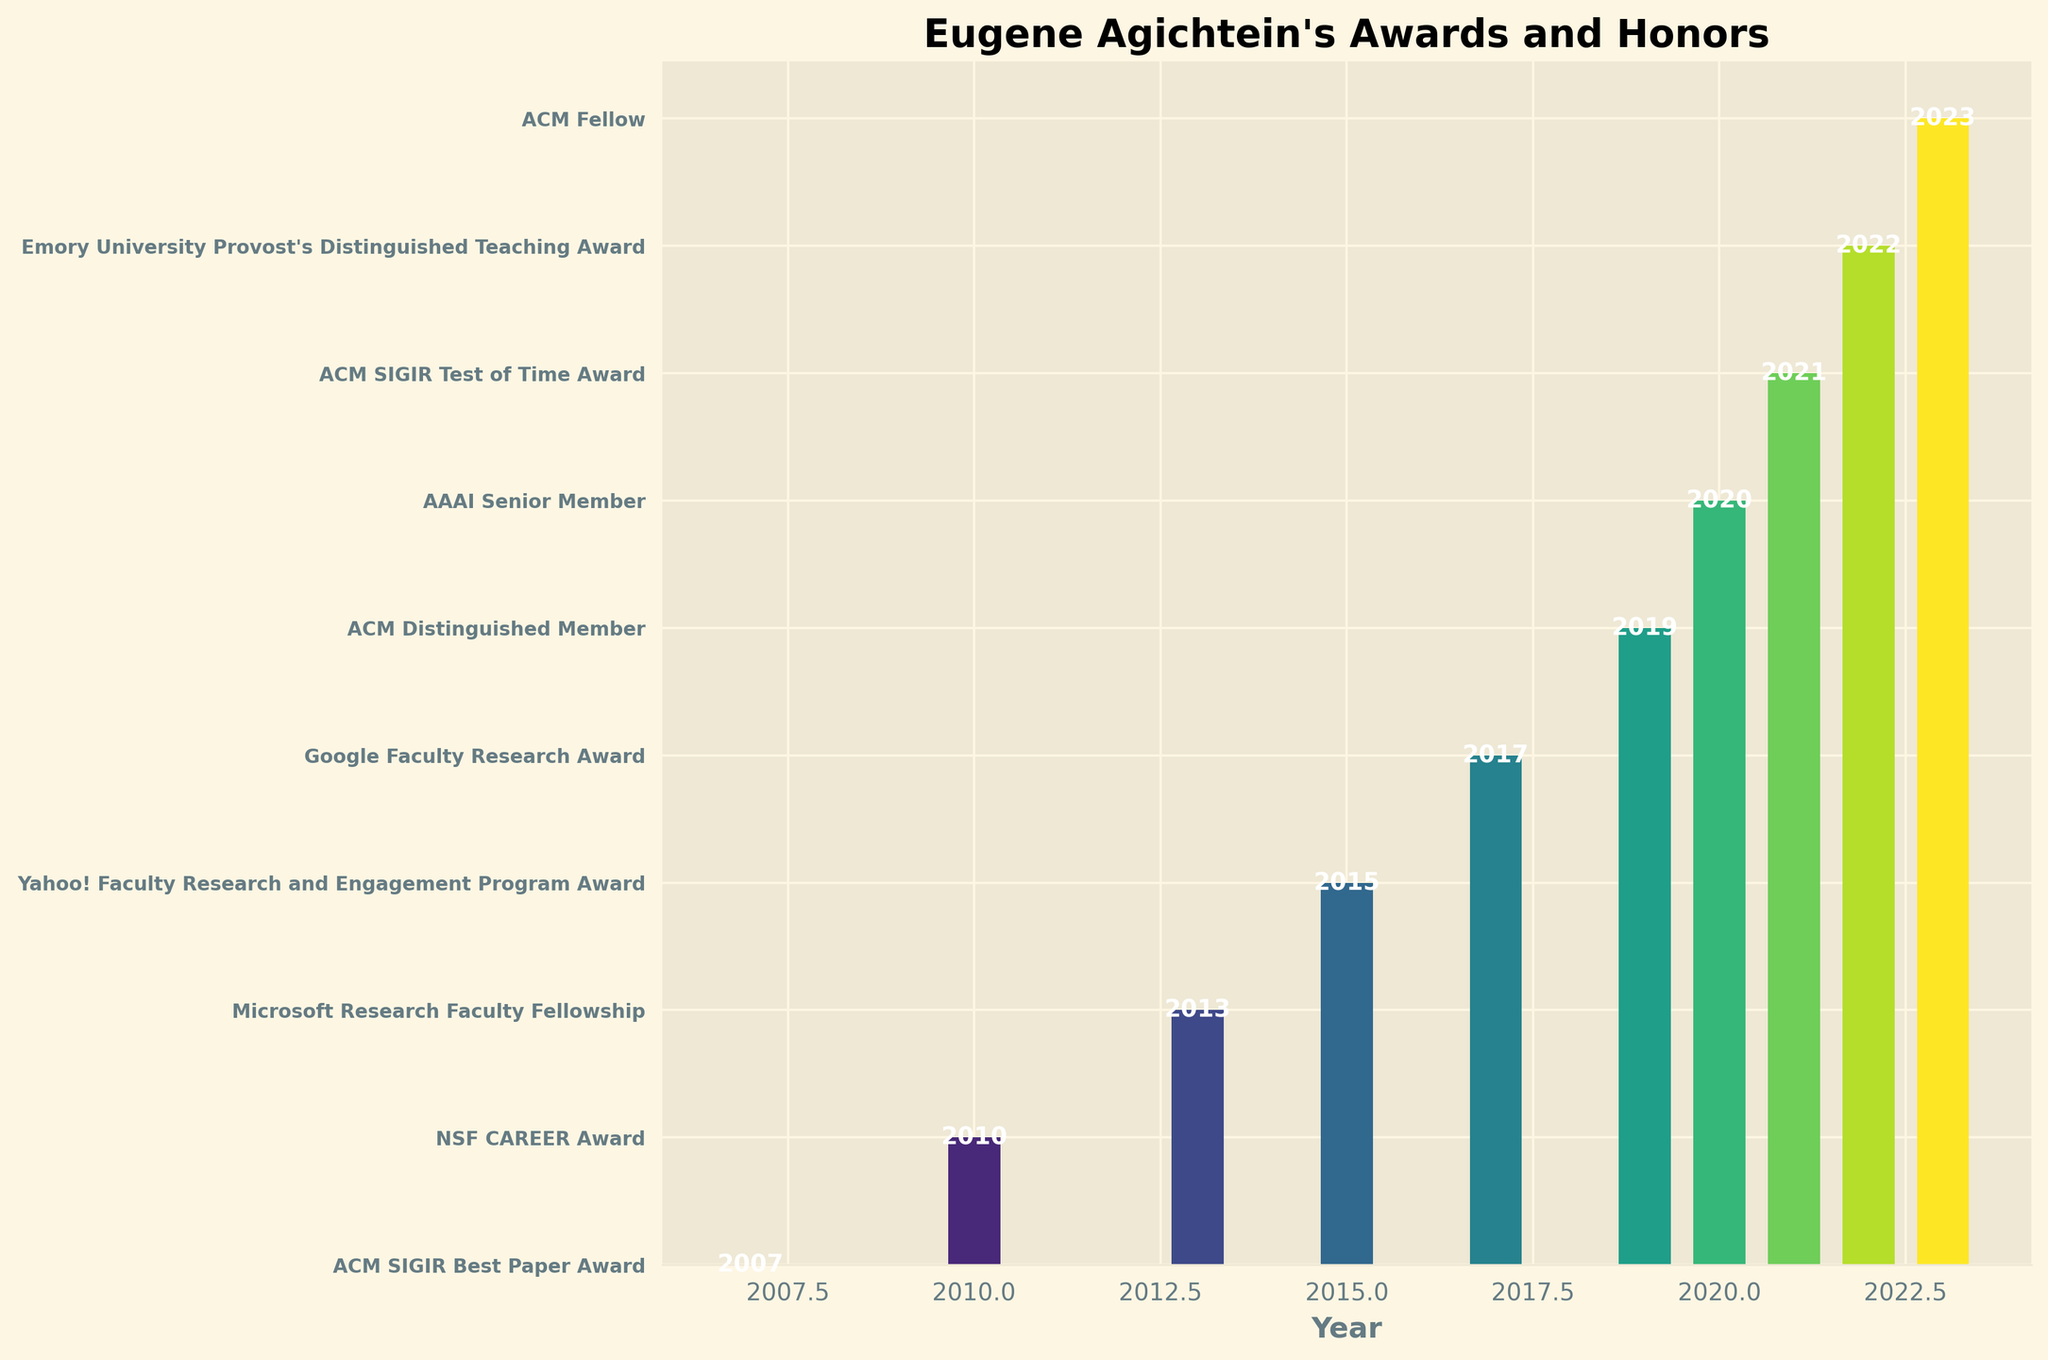Which year did Eugene Agichtein receive the ACM SIGIR Best Paper Award? The bar representing the ACM SIGIR Best Paper Award is labeled with the year 2007.
Answer: 2007 Which award did Eugene Agichtein receive in 2019? The bar corresponding to the year 2019 is labeled with "ACM Distinguished Member."
Answer: ACM Distinguished Member Compare the number of awards received by Eugene Agichtein before and after 2015. Which period has more awards? Count the awards before 2015 (2007, 2010, 2013) which are 3, and after 2015 (2017, 2019, 2020, 2021, 2022, 2023) which are 6. There are more awards after 2015.
Answer: After 2015 In which years did Eugene Agichtein receive awards from major tech companies (Google, Yahoo!, Microsoft)? Identify the awards given by tech companies: Microsoft Research Faculty Fellowship (2013), Yahoo! Faculty Research and Engagement Program Award (2015), Google Faculty Research Award (2017).
Answer: 2013, 2015, 2017 How many years passed between Eugene Agichtein's initial ACM SIGIR Best Paper Award and his recent ACM Fellow recognition? Subtract the initial year (2007) from the recent year (2023). 2023 - 2007 = 16 years.
Answer: 16 Which two awards were given in consecutive years from 2020 to 2021, and what were they? Identify consecutive years: 2020 (AAAI Senior Member) and 2021 (ACM SIGIR Test of Time Award).
Answer: AAAI Senior Member and ACM SIGIR Test of Time Award How many teaching-related awards has Eugene Agichtein received, and which one(s)? Scan for teaching-related words: Emory University Provost's Distinguished Teaching Award from 2022. There is only 1 teaching-related award.
Answer: 1 What are the two most recent awards received by Eugene Agichtein, and in which years were they received? Identify the two most recent years: 2022 (Emory University Provost's Distinguished Teaching Award) and 2023 (ACM Fellow).
Answer: Emory University Provost's Distinguished Teaching Award (2022) and ACM Fellow (2023) Which bar is colored the darkest, and what award does it represent? The bar's color darkens progressively from left (earliest) to right (latest). Therefore, the darkest bar is the last one, representing the ACM Fellow award in 2023.
Answer: ACM Fellow 